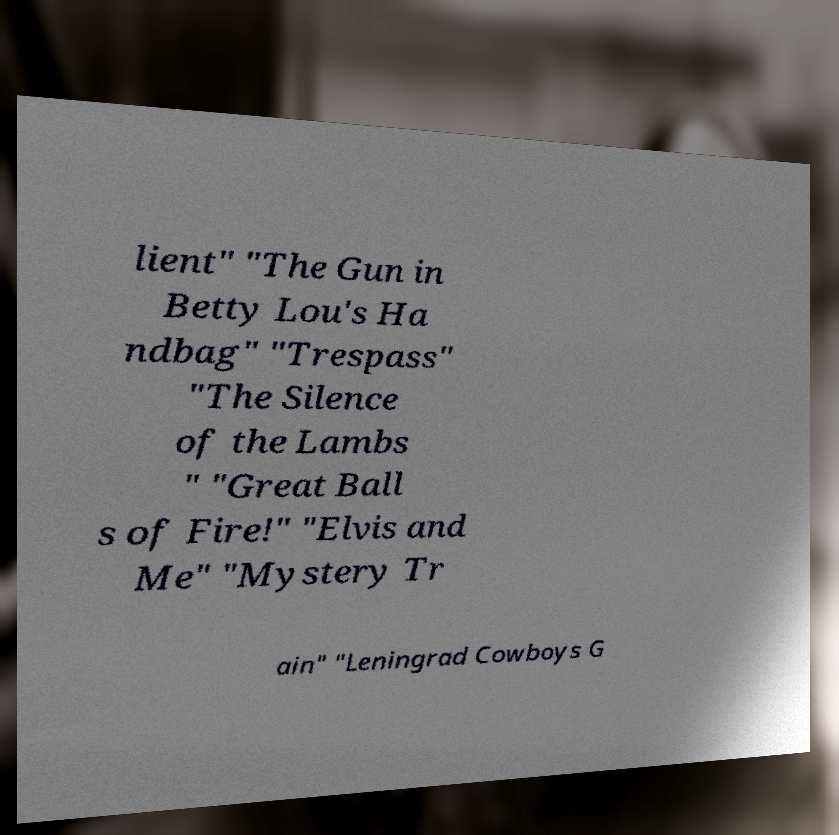For documentation purposes, I need the text within this image transcribed. Could you provide that? lient" "The Gun in Betty Lou's Ha ndbag" "Trespass" "The Silence of the Lambs " "Great Ball s of Fire!" "Elvis and Me" "Mystery Tr ain" "Leningrad Cowboys G 